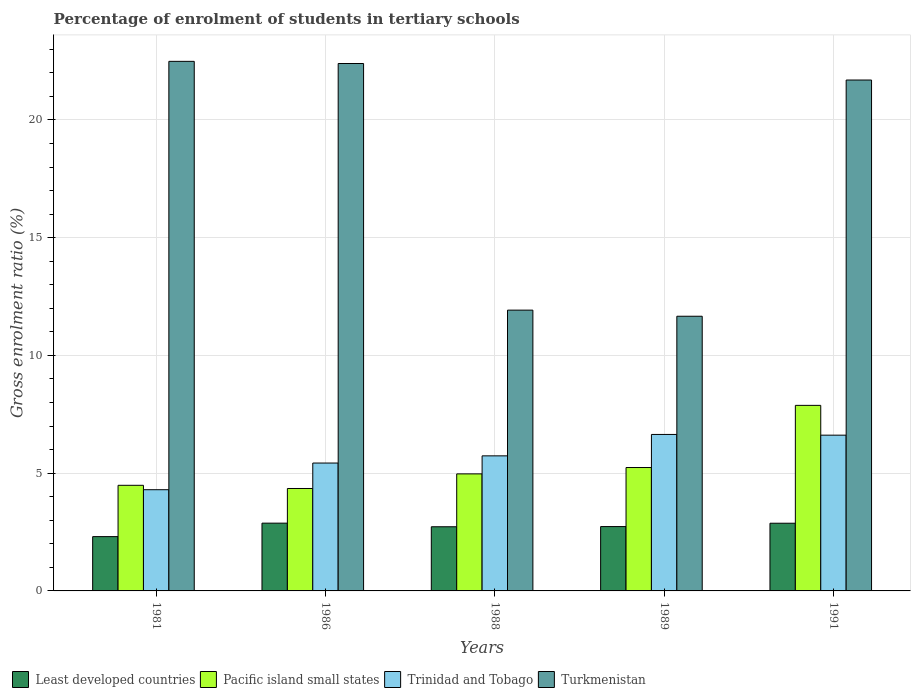How many bars are there on the 4th tick from the left?
Offer a very short reply. 4. What is the label of the 4th group of bars from the left?
Provide a succinct answer. 1989. In how many cases, is the number of bars for a given year not equal to the number of legend labels?
Your response must be concise. 0. What is the percentage of students enrolled in tertiary schools in Pacific island small states in 1986?
Give a very brief answer. 4.35. Across all years, what is the maximum percentage of students enrolled in tertiary schools in Least developed countries?
Offer a terse response. 2.88. Across all years, what is the minimum percentage of students enrolled in tertiary schools in Pacific island small states?
Your answer should be compact. 4.35. In which year was the percentage of students enrolled in tertiary schools in Turkmenistan maximum?
Your answer should be very brief. 1981. In which year was the percentage of students enrolled in tertiary schools in Turkmenistan minimum?
Your answer should be compact. 1989. What is the total percentage of students enrolled in tertiary schools in Trinidad and Tobago in the graph?
Keep it short and to the point. 28.73. What is the difference between the percentage of students enrolled in tertiary schools in Trinidad and Tobago in 1986 and that in 1988?
Provide a succinct answer. -0.31. What is the difference between the percentage of students enrolled in tertiary schools in Least developed countries in 1981 and the percentage of students enrolled in tertiary schools in Pacific island small states in 1989?
Make the answer very short. -2.93. What is the average percentage of students enrolled in tertiary schools in Pacific island small states per year?
Keep it short and to the point. 5.39. In the year 1981, what is the difference between the percentage of students enrolled in tertiary schools in Least developed countries and percentage of students enrolled in tertiary schools in Trinidad and Tobago?
Ensure brevity in your answer.  -1.99. In how many years, is the percentage of students enrolled in tertiary schools in Turkmenistan greater than 15 %?
Offer a terse response. 3. What is the ratio of the percentage of students enrolled in tertiary schools in Pacific island small states in 1988 to that in 1989?
Your answer should be compact. 0.95. What is the difference between the highest and the second highest percentage of students enrolled in tertiary schools in Least developed countries?
Your response must be concise. 0. What is the difference between the highest and the lowest percentage of students enrolled in tertiary schools in Least developed countries?
Your response must be concise. 0.57. In how many years, is the percentage of students enrolled in tertiary schools in Least developed countries greater than the average percentage of students enrolled in tertiary schools in Least developed countries taken over all years?
Your answer should be compact. 4. Is it the case that in every year, the sum of the percentage of students enrolled in tertiary schools in Trinidad and Tobago and percentage of students enrolled in tertiary schools in Turkmenistan is greater than the sum of percentage of students enrolled in tertiary schools in Least developed countries and percentage of students enrolled in tertiary schools in Pacific island small states?
Offer a terse response. Yes. What does the 3rd bar from the left in 1986 represents?
Offer a very short reply. Trinidad and Tobago. What does the 3rd bar from the right in 1988 represents?
Provide a short and direct response. Pacific island small states. How many bars are there?
Provide a succinct answer. 20. Are all the bars in the graph horizontal?
Keep it short and to the point. No. How many years are there in the graph?
Offer a very short reply. 5. What is the difference between two consecutive major ticks on the Y-axis?
Make the answer very short. 5. Does the graph contain any zero values?
Ensure brevity in your answer.  No. Does the graph contain grids?
Provide a short and direct response. Yes. How are the legend labels stacked?
Make the answer very short. Horizontal. What is the title of the graph?
Offer a terse response. Percentage of enrolment of students in tertiary schools. What is the label or title of the X-axis?
Your answer should be compact. Years. What is the Gross enrolment ratio (%) in Least developed countries in 1981?
Keep it short and to the point. 2.31. What is the Gross enrolment ratio (%) in Pacific island small states in 1981?
Your response must be concise. 4.49. What is the Gross enrolment ratio (%) in Trinidad and Tobago in 1981?
Ensure brevity in your answer.  4.3. What is the Gross enrolment ratio (%) in Turkmenistan in 1981?
Provide a short and direct response. 22.49. What is the Gross enrolment ratio (%) in Least developed countries in 1986?
Give a very brief answer. 2.88. What is the Gross enrolment ratio (%) in Pacific island small states in 1986?
Offer a very short reply. 4.35. What is the Gross enrolment ratio (%) of Trinidad and Tobago in 1986?
Your answer should be compact. 5.43. What is the Gross enrolment ratio (%) in Turkmenistan in 1986?
Keep it short and to the point. 22.4. What is the Gross enrolment ratio (%) in Least developed countries in 1988?
Your answer should be compact. 2.72. What is the Gross enrolment ratio (%) of Pacific island small states in 1988?
Your answer should be compact. 4.97. What is the Gross enrolment ratio (%) of Trinidad and Tobago in 1988?
Your answer should be compact. 5.74. What is the Gross enrolment ratio (%) of Turkmenistan in 1988?
Your answer should be compact. 11.92. What is the Gross enrolment ratio (%) of Least developed countries in 1989?
Make the answer very short. 2.73. What is the Gross enrolment ratio (%) of Pacific island small states in 1989?
Keep it short and to the point. 5.24. What is the Gross enrolment ratio (%) in Trinidad and Tobago in 1989?
Offer a terse response. 6.65. What is the Gross enrolment ratio (%) of Turkmenistan in 1989?
Your response must be concise. 11.66. What is the Gross enrolment ratio (%) of Least developed countries in 1991?
Make the answer very short. 2.87. What is the Gross enrolment ratio (%) of Pacific island small states in 1991?
Offer a terse response. 7.88. What is the Gross enrolment ratio (%) in Trinidad and Tobago in 1991?
Your answer should be compact. 6.61. What is the Gross enrolment ratio (%) in Turkmenistan in 1991?
Your answer should be very brief. 21.7. Across all years, what is the maximum Gross enrolment ratio (%) in Least developed countries?
Offer a very short reply. 2.88. Across all years, what is the maximum Gross enrolment ratio (%) of Pacific island small states?
Your answer should be compact. 7.88. Across all years, what is the maximum Gross enrolment ratio (%) of Trinidad and Tobago?
Your response must be concise. 6.65. Across all years, what is the maximum Gross enrolment ratio (%) of Turkmenistan?
Offer a terse response. 22.49. Across all years, what is the minimum Gross enrolment ratio (%) in Least developed countries?
Keep it short and to the point. 2.31. Across all years, what is the minimum Gross enrolment ratio (%) of Pacific island small states?
Make the answer very short. 4.35. Across all years, what is the minimum Gross enrolment ratio (%) of Trinidad and Tobago?
Your response must be concise. 4.3. Across all years, what is the minimum Gross enrolment ratio (%) of Turkmenistan?
Provide a succinct answer. 11.66. What is the total Gross enrolment ratio (%) of Least developed countries in the graph?
Your response must be concise. 13.52. What is the total Gross enrolment ratio (%) in Pacific island small states in the graph?
Provide a short and direct response. 26.93. What is the total Gross enrolment ratio (%) in Trinidad and Tobago in the graph?
Offer a terse response. 28.73. What is the total Gross enrolment ratio (%) of Turkmenistan in the graph?
Ensure brevity in your answer.  90.17. What is the difference between the Gross enrolment ratio (%) in Least developed countries in 1981 and that in 1986?
Your answer should be very brief. -0.57. What is the difference between the Gross enrolment ratio (%) in Pacific island small states in 1981 and that in 1986?
Offer a very short reply. 0.14. What is the difference between the Gross enrolment ratio (%) of Trinidad and Tobago in 1981 and that in 1986?
Make the answer very short. -1.13. What is the difference between the Gross enrolment ratio (%) of Turkmenistan in 1981 and that in 1986?
Offer a very short reply. 0.09. What is the difference between the Gross enrolment ratio (%) in Least developed countries in 1981 and that in 1988?
Offer a very short reply. -0.42. What is the difference between the Gross enrolment ratio (%) in Pacific island small states in 1981 and that in 1988?
Your response must be concise. -0.48. What is the difference between the Gross enrolment ratio (%) in Trinidad and Tobago in 1981 and that in 1988?
Offer a terse response. -1.44. What is the difference between the Gross enrolment ratio (%) in Turkmenistan in 1981 and that in 1988?
Ensure brevity in your answer.  10.57. What is the difference between the Gross enrolment ratio (%) in Least developed countries in 1981 and that in 1989?
Offer a terse response. -0.43. What is the difference between the Gross enrolment ratio (%) in Pacific island small states in 1981 and that in 1989?
Provide a succinct answer. -0.76. What is the difference between the Gross enrolment ratio (%) in Trinidad and Tobago in 1981 and that in 1989?
Provide a short and direct response. -2.35. What is the difference between the Gross enrolment ratio (%) of Turkmenistan in 1981 and that in 1989?
Keep it short and to the point. 10.82. What is the difference between the Gross enrolment ratio (%) in Least developed countries in 1981 and that in 1991?
Your answer should be compact. -0.57. What is the difference between the Gross enrolment ratio (%) in Pacific island small states in 1981 and that in 1991?
Offer a terse response. -3.39. What is the difference between the Gross enrolment ratio (%) in Trinidad and Tobago in 1981 and that in 1991?
Your response must be concise. -2.32. What is the difference between the Gross enrolment ratio (%) of Turkmenistan in 1981 and that in 1991?
Keep it short and to the point. 0.79. What is the difference between the Gross enrolment ratio (%) of Least developed countries in 1986 and that in 1988?
Your answer should be very brief. 0.15. What is the difference between the Gross enrolment ratio (%) of Pacific island small states in 1986 and that in 1988?
Provide a short and direct response. -0.62. What is the difference between the Gross enrolment ratio (%) in Trinidad and Tobago in 1986 and that in 1988?
Your answer should be compact. -0.31. What is the difference between the Gross enrolment ratio (%) in Turkmenistan in 1986 and that in 1988?
Give a very brief answer. 10.47. What is the difference between the Gross enrolment ratio (%) in Least developed countries in 1986 and that in 1989?
Offer a terse response. 0.15. What is the difference between the Gross enrolment ratio (%) of Pacific island small states in 1986 and that in 1989?
Keep it short and to the point. -0.89. What is the difference between the Gross enrolment ratio (%) in Trinidad and Tobago in 1986 and that in 1989?
Provide a short and direct response. -1.21. What is the difference between the Gross enrolment ratio (%) of Turkmenistan in 1986 and that in 1989?
Your response must be concise. 10.73. What is the difference between the Gross enrolment ratio (%) in Least developed countries in 1986 and that in 1991?
Provide a succinct answer. 0. What is the difference between the Gross enrolment ratio (%) of Pacific island small states in 1986 and that in 1991?
Offer a very short reply. -3.53. What is the difference between the Gross enrolment ratio (%) in Trinidad and Tobago in 1986 and that in 1991?
Provide a short and direct response. -1.18. What is the difference between the Gross enrolment ratio (%) of Turkmenistan in 1986 and that in 1991?
Your answer should be compact. 0.7. What is the difference between the Gross enrolment ratio (%) of Least developed countries in 1988 and that in 1989?
Offer a terse response. -0.01. What is the difference between the Gross enrolment ratio (%) of Pacific island small states in 1988 and that in 1989?
Offer a terse response. -0.27. What is the difference between the Gross enrolment ratio (%) of Trinidad and Tobago in 1988 and that in 1989?
Your response must be concise. -0.91. What is the difference between the Gross enrolment ratio (%) of Turkmenistan in 1988 and that in 1989?
Make the answer very short. 0.26. What is the difference between the Gross enrolment ratio (%) in Least developed countries in 1988 and that in 1991?
Offer a terse response. -0.15. What is the difference between the Gross enrolment ratio (%) in Pacific island small states in 1988 and that in 1991?
Provide a succinct answer. -2.91. What is the difference between the Gross enrolment ratio (%) in Trinidad and Tobago in 1988 and that in 1991?
Give a very brief answer. -0.88. What is the difference between the Gross enrolment ratio (%) of Turkmenistan in 1988 and that in 1991?
Make the answer very short. -9.77. What is the difference between the Gross enrolment ratio (%) in Least developed countries in 1989 and that in 1991?
Keep it short and to the point. -0.14. What is the difference between the Gross enrolment ratio (%) of Pacific island small states in 1989 and that in 1991?
Give a very brief answer. -2.64. What is the difference between the Gross enrolment ratio (%) of Trinidad and Tobago in 1989 and that in 1991?
Your answer should be very brief. 0.03. What is the difference between the Gross enrolment ratio (%) of Turkmenistan in 1989 and that in 1991?
Your response must be concise. -10.03. What is the difference between the Gross enrolment ratio (%) in Least developed countries in 1981 and the Gross enrolment ratio (%) in Pacific island small states in 1986?
Keep it short and to the point. -2.04. What is the difference between the Gross enrolment ratio (%) of Least developed countries in 1981 and the Gross enrolment ratio (%) of Trinidad and Tobago in 1986?
Your response must be concise. -3.12. What is the difference between the Gross enrolment ratio (%) of Least developed countries in 1981 and the Gross enrolment ratio (%) of Turkmenistan in 1986?
Your response must be concise. -20.09. What is the difference between the Gross enrolment ratio (%) of Pacific island small states in 1981 and the Gross enrolment ratio (%) of Trinidad and Tobago in 1986?
Offer a terse response. -0.95. What is the difference between the Gross enrolment ratio (%) in Pacific island small states in 1981 and the Gross enrolment ratio (%) in Turkmenistan in 1986?
Ensure brevity in your answer.  -17.91. What is the difference between the Gross enrolment ratio (%) in Trinidad and Tobago in 1981 and the Gross enrolment ratio (%) in Turkmenistan in 1986?
Give a very brief answer. -18.1. What is the difference between the Gross enrolment ratio (%) of Least developed countries in 1981 and the Gross enrolment ratio (%) of Pacific island small states in 1988?
Offer a terse response. -2.66. What is the difference between the Gross enrolment ratio (%) of Least developed countries in 1981 and the Gross enrolment ratio (%) of Trinidad and Tobago in 1988?
Your answer should be very brief. -3.43. What is the difference between the Gross enrolment ratio (%) of Least developed countries in 1981 and the Gross enrolment ratio (%) of Turkmenistan in 1988?
Make the answer very short. -9.62. What is the difference between the Gross enrolment ratio (%) in Pacific island small states in 1981 and the Gross enrolment ratio (%) in Trinidad and Tobago in 1988?
Your answer should be very brief. -1.25. What is the difference between the Gross enrolment ratio (%) in Pacific island small states in 1981 and the Gross enrolment ratio (%) in Turkmenistan in 1988?
Keep it short and to the point. -7.44. What is the difference between the Gross enrolment ratio (%) in Trinidad and Tobago in 1981 and the Gross enrolment ratio (%) in Turkmenistan in 1988?
Give a very brief answer. -7.63. What is the difference between the Gross enrolment ratio (%) of Least developed countries in 1981 and the Gross enrolment ratio (%) of Pacific island small states in 1989?
Ensure brevity in your answer.  -2.93. What is the difference between the Gross enrolment ratio (%) in Least developed countries in 1981 and the Gross enrolment ratio (%) in Trinidad and Tobago in 1989?
Your response must be concise. -4.34. What is the difference between the Gross enrolment ratio (%) of Least developed countries in 1981 and the Gross enrolment ratio (%) of Turkmenistan in 1989?
Your response must be concise. -9.36. What is the difference between the Gross enrolment ratio (%) of Pacific island small states in 1981 and the Gross enrolment ratio (%) of Trinidad and Tobago in 1989?
Your answer should be very brief. -2.16. What is the difference between the Gross enrolment ratio (%) in Pacific island small states in 1981 and the Gross enrolment ratio (%) in Turkmenistan in 1989?
Give a very brief answer. -7.18. What is the difference between the Gross enrolment ratio (%) of Trinidad and Tobago in 1981 and the Gross enrolment ratio (%) of Turkmenistan in 1989?
Ensure brevity in your answer.  -7.37. What is the difference between the Gross enrolment ratio (%) of Least developed countries in 1981 and the Gross enrolment ratio (%) of Pacific island small states in 1991?
Your response must be concise. -5.57. What is the difference between the Gross enrolment ratio (%) in Least developed countries in 1981 and the Gross enrolment ratio (%) in Trinidad and Tobago in 1991?
Offer a very short reply. -4.31. What is the difference between the Gross enrolment ratio (%) in Least developed countries in 1981 and the Gross enrolment ratio (%) in Turkmenistan in 1991?
Give a very brief answer. -19.39. What is the difference between the Gross enrolment ratio (%) in Pacific island small states in 1981 and the Gross enrolment ratio (%) in Trinidad and Tobago in 1991?
Your answer should be compact. -2.13. What is the difference between the Gross enrolment ratio (%) of Pacific island small states in 1981 and the Gross enrolment ratio (%) of Turkmenistan in 1991?
Provide a short and direct response. -17.21. What is the difference between the Gross enrolment ratio (%) of Trinidad and Tobago in 1981 and the Gross enrolment ratio (%) of Turkmenistan in 1991?
Give a very brief answer. -17.4. What is the difference between the Gross enrolment ratio (%) of Least developed countries in 1986 and the Gross enrolment ratio (%) of Pacific island small states in 1988?
Your response must be concise. -2.09. What is the difference between the Gross enrolment ratio (%) in Least developed countries in 1986 and the Gross enrolment ratio (%) in Trinidad and Tobago in 1988?
Your answer should be very brief. -2.86. What is the difference between the Gross enrolment ratio (%) in Least developed countries in 1986 and the Gross enrolment ratio (%) in Turkmenistan in 1988?
Offer a very short reply. -9.05. What is the difference between the Gross enrolment ratio (%) in Pacific island small states in 1986 and the Gross enrolment ratio (%) in Trinidad and Tobago in 1988?
Give a very brief answer. -1.39. What is the difference between the Gross enrolment ratio (%) in Pacific island small states in 1986 and the Gross enrolment ratio (%) in Turkmenistan in 1988?
Give a very brief answer. -7.57. What is the difference between the Gross enrolment ratio (%) in Trinidad and Tobago in 1986 and the Gross enrolment ratio (%) in Turkmenistan in 1988?
Your answer should be compact. -6.49. What is the difference between the Gross enrolment ratio (%) of Least developed countries in 1986 and the Gross enrolment ratio (%) of Pacific island small states in 1989?
Your response must be concise. -2.36. What is the difference between the Gross enrolment ratio (%) of Least developed countries in 1986 and the Gross enrolment ratio (%) of Trinidad and Tobago in 1989?
Give a very brief answer. -3.77. What is the difference between the Gross enrolment ratio (%) of Least developed countries in 1986 and the Gross enrolment ratio (%) of Turkmenistan in 1989?
Provide a succinct answer. -8.79. What is the difference between the Gross enrolment ratio (%) of Pacific island small states in 1986 and the Gross enrolment ratio (%) of Trinidad and Tobago in 1989?
Provide a short and direct response. -2.3. What is the difference between the Gross enrolment ratio (%) of Pacific island small states in 1986 and the Gross enrolment ratio (%) of Turkmenistan in 1989?
Offer a very short reply. -7.32. What is the difference between the Gross enrolment ratio (%) of Trinidad and Tobago in 1986 and the Gross enrolment ratio (%) of Turkmenistan in 1989?
Your response must be concise. -6.23. What is the difference between the Gross enrolment ratio (%) of Least developed countries in 1986 and the Gross enrolment ratio (%) of Pacific island small states in 1991?
Make the answer very short. -5. What is the difference between the Gross enrolment ratio (%) of Least developed countries in 1986 and the Gross enrolment ratio (%) of Trinidad and Tobago in 1991?
Your answer should be very brief. -3.74. What is the difference between the Gross enrolment ratio (%) in Least developed countries in 1986 and the Gross enrolment ratio (%) in Turkmenistan in 1991?
Offer a terse response. -18.82. What is the difference between the Gross enrolment ratio (%) in Pacific island small states in 1986 and the Gross enrolment ratio (%) in Trinidad and Tobago in 1991?
Give a very brief answer. -2.27. What is the difference between the Gross enrolment ratio (%) in Pacific island small states in 1986 and the Gross enrolment ratio (%) in Turkmenistan in 1991?
Your answer should be very brief. -17.35. What is the difference between the Gross enrolment ratio (%) in Trinidad and Tobago in 1986 and the Gross enrolment ratio (%) in Turkmenistan in 1991?
Your answer should be compact. -16.27. What is the difference between the Gross enrolment ratio (%) of Least developed countries in 1988 and the Gross enrolment ratio (%) of Pacific island small states in 1989?
Your answer should be very brief. -2.52. What is the difference between the Gross enrolment ratio (%) in Least developed countries in 1988 and the Gross enrolment ratio (%) in Trinidad and Tobago in 1989?
Provide a succinct answer. -3.92. What is the difference between the Gross enrolment ratio (%) in Least developed countries in 1988 and the Gross enrolment ratio (%) in Turkmenistan in 1989?
Offer a very short reply. -8.94. What is the difference between the Gross enrolment ratio (%) of Pacific island small states in 1988 and the Gross enrolment ratio (%) of Trinidad and Tobago in 1989?
Provide a short and direct response. -1.68. What is the difference between the Gross enrolment ratio (%) of Pacific island small states in 1988 and the Gross enrolment ratio (%) of Turkmenistan in 1989?
Ensure brevity in your answer.  -6.69. What is the difference between the Gross enrolment ratio (%) of Trinidad and Tobago in 1988 and the Gross enrolment ratio (%) of Turkmenistan in 1989?
Your answer should be compact. -5.93. What is the difference between the Gross enrolment ratio (%) of Least developed countries in 1988 and the Gross enrolment ratio (%) of Pacific island small states in 1991?
Your answer should be very brief. -5.16. What is the difference between the Gross enrolment ratio (%) of Least developed countries in 1988 and the Gross enrolment ratio (%) of Trinidad and Tobago in 1991?
Your answer should be very brief. -3.89. What is the difference between the Gross enrolment ratio (%) in Least developed countries in 1988 and the Gross enrolment ratio (%) in Turkmenistan in 1991?
Your answer should be very brief. -18.97. What is the difference between the Gross enrolment ratio (%) of Pacific island small states in 1988 and the Gross enrolment ratio (%) of Trinidad and Tobago in 1991?
Your response must be concise. -1.64. What is the difference between the Gross enrolment ratio (%) in Pacific island small states in 1988 and the Gross enrolment ratio (%) in Turkmenistan in 1991?
Provide a succinct answer. -16.73. What is the difference between the Gross enrolment ratio (%) in Trinidad and Tobago in 1988 and the Gross enrolment ratio (%) in Turkmenistan in 1991?
Offer a terse response. -15.96. What is the difference between the Gross enrolment ratio (%) in Least developed countries in 1989 and the Gross enrolment ratio (%) in Pacific island small states in 1991?
Provide a short and direct response. -5.15. What is the difference between the Gross enrolment ratio (%) in Least developed countries in 1989 and the Gross enrolment ratio (%) in Trinidad and Tobago in 1991?
Offer a terse response. -3.88. What is the difference between the Gross enrolment ratio (%) of Least developed countries in 1989 and the Gross enrolment ratio (%) of Turkmenistan in 1991?
Offer a very short reply. -18.96. What is the difference between the Gross enrolment ratio (%) in Pacific island small states in 1989 and the Gross enrolment ratio (%) in Trinidad and Tobago in 1991?
Your response must be concise. -1.37. What is the difference between the Gross enrolment ratio (%) in Pacific island small states in 1989 and the Gross enrolment ratio (%) in Turkmenistan in 1991?
Your response must be concise. -16.46. What is the difference between the Gross enrolment ratio (%) in Trinidad and Tobago in 1989 and the Gross enrolment ratio (%) in Turkmenistan in 1991?
Keep it short and to the point. -15.05. What is the average Gross enrolment ratio (%) in Least developed countries per year?
Your answer should be very brief. 2.7. What is the average Gross enrolment ratio (%) of Pacific island small states per year?
Provide a short and direct response. 5.39. What is the average Gross enrolment ratio (%) of Trinidad and Tobago per year?
Offer a terse response. 5.75. What is the average Gross enrolment ratio (%) in Turkmenistan per year?
Provide a short and direct response. 18.03. In the year 1981, what is the difference between the Gross enrolment ratio (%) of Least developed countries and Gross enrolment ratio (%) of Pacific island small states?
Offer a very short reply. -2.18. In the year 1981, what is the difference between the Gross enrolment ratio (%) of Least developed countries and Gross enrolment ratio (%) of Trinidad and Tobago?
Your answer should be very brief. -1.99. In the year 1981, what is the difference between the Gross enrolment ratio (%) in Least developed countries and Gross enrolment ratio (%) in Turkmenistan?
Make the answer very short. -20.18. In the year 1981, what is the difference between the Gross enrolment ratio (%) in Pacific island small states and Gross enrolment ratio (%) in Trinidad and Tobago?
Make the answer very short. 0.19. In the year 1981, what is the difference between the Gross enrolment ratio (%) of Pacific island small states and Gross enrolment ratio (%) of Turkmenistan?
Provide a succinct answer. -18. In the year 1981, what is the difference between the Gross enrolment ratio (%) of Trinidad and Tobago and Gross enrolment ratio (%) of Turkmenistan?
Your answer should be compact. -18.19. In the year 1986, what is the difference between the Gross enrolment ratio (%) of Least developed countries and Gross enrolment ratio (%) of Pacific island small states?
Offer a terse response. -1.47. In the year 1986, what is the difference between the Gross enrolment ratio (%) of Least developed countries and Gross enrolment ratio (%) of Trinidad and Tobago?
Your response must be concise. -2.55. In the year 1986, what is the difference between the Gross enrolment ratio (%) of Least developed countries and Gross enrolment ratio (%) of Turkmenistan?
Offer a terse response. -19.52. In the year 1986, what is the difference between the Gross enrolment ratio (%) of Pacific island small states and Gross enrolment ratio (%) of Trinidad and Tobago?
Provide a succinct answer. -1.08. In the year 1986, what is the difference between the Gross enrolment ratio (%) of Pacific island small states and Gross enrolment ratio (%) of Turkmenistan?
Provide a short and direct response. -18.05. In the year 1986, what is the difference between the Gross enrolment ratio (%) in Trinidad and Tobago and Gross enrolment ratio (%) in Turkmenistan?
Your answer should be very brief. -16.97. In the year 1988, what is the difference between the Gross enrolment ratio (%) in Least developed countries and Gross enrolment ratio (%) in Pacific island small states?
Keep it short and to the point. -2.25. In the year 1988, what is the difference between the Gross enrolment ratio (%) of Least developed countries and Gross enrolment ratio (%) of Trinidad and Tobago?
Your response must be concise. -3.01. In the year 1988, what is the difference between the Gross enrolment ratio (%) of Least developed countries and Gross enrolment ratio (%) of Turkmenistan?
Give a very brief answer. -9.2. In the year 1988, what is the difference between the Gross enrolment ratio (%) in Pacific island small states and Gross enrolment ratio (%) in Trinidad and Tobago?
Offer a very short reply. -0.77. In the year 1988, what is the difference between the Gross enrolment ratio (%) of Pacific island small states and Gross enrolment ratio (%) of Turkmenistan?
Your answer should be very brief. -6.95. In the year 1988, what is the difference between the Gross enrolment ratio (%) in Trinidad and Tobago and Gross enrolment ratio (%) in Turkmenistan?
Provide a short and direct response. -6.19. In the year 1989, what is the difference between the Gross enrolment ratio (%) in Least developed countries and Gross enrolment ratio (%) in Pacific island small states?
Ensure brevity in your answer.  -2.51. In the year 1989, what is the difference between the Gross enrolment ratio (%) of Least developed countries and Gross enrolment ratio (%) of Trinidad and Tobago?
Give a very brief answer. -3.91. In the year 1989, what is the difference between the Gross enrolment ratio (%) in Least developed countries and Gross enrolment ratio (%) in Turkmenistan?
Provide a succinct answer. -8.93. In the year 1989, what is the difference between the Gross enrolment ratio (%) in Pacific island small states and Gross enrolment ratio (%) in Trinidad and Tobago?
Keep it short and to the point. -1.4. In the year 1989, what is the difference between the Gross enrolment ratio (%) of Pacific island small states and Gross enrolment ratio (%) of Turkmenistan?
Your answer should be very brief. -6.42. In the year 1989, what is the difference between the Gross enrolment ratio (%) of Trinidad and Tobago and Gross enrolment ratio (%) of Turkmenistan?
Provide a succinct answer. -5.02. In the year 1991, what is the difference between the Gross enrolment ratio (%) in Least developed countries and Gross enrolment ratio (%) in Pacific island small states?
Your response must be concise. -5.01. In the year 1991, what is the difference between the Gross enrolment ratio (%) in Least developed countries and Gross enrolment ratio (%) in Trinidad and Tobago?
Provide a succinct answer. -3.74. In the year 1991, what is the difference between the Gross enrolment ratio (%) of Least developed countries and Gross enrolment ratio (%) of Turkmenistan?
Offer a very short reply. -18.82. In the year 1991, what is the difference between the Gross enrolment ratio (%) of Pacific island small states and Gross enrolment ratio (%) of Trinidad and Tobago?
Offer a terse response. 1.27. In the year 1991, what is the difference between the Gross enrolment ratio (%) in Pacific island small states and Gross enrolment ratio (%) in Turkmenistan?
Offer a terse response. -13.82. In the year 1991, what is the difference between the Gross enrolment ratio (%) in Trinidad and Tobago and Gross enrolment ratio (%) in Turkmenistan?
Offer a very short reply. -15.08. What is the ratio of the Gross enrolment ratio (%) in Least developed countries in 1981 to that in 1986?
Offer a terse response. 0.8. What is the ratio of the Gross enrolment ratio (%) in Pacific island small states in 1981 to that in 1986?
Your response must be concise. 1.03. What is the ratio of the Gross enrolment ratio (%) in Trinidad and Tobago in 1981 to that in 1986?
Your response must be concise. 0.79. What is the ratio of the Gross enrolment ratio (%) in Least developed countries in 1981 to that in 1988?
Provide a succinct answer. 0.85. What is the ratio of the Gross enrolment ratio (%) in Pacific island small states in 1981 to that in 1988?
Provide a short and direct response. 0.9. What is the ratio of the Gross enrolment ratio (%) in Trinidad and Tobago in 1981 to that in 1988?
Ensure brevity in your answer.  0.75. What is the ratio of the Gross enrolment ratio (%) of Turkmenistan in 1981 to that in 1988?
Give a very brief answer. 1.89. What is the ratio of the Gross enrolment ratio (%) in Least developed countries in 1981 to that in 1989?
Your answer should be very brief. 0.84. What is the ratio of the Gross enrolment ratio (%) in Pacific island small states in 1981 to that in 1989?
Make the answer very short. 0.86. What is the ratio of the Gross enrolment ratio (%) in Trinidad and Tobago in 1981 to that in 1989?
Your answer should be very brief. 0.65. What is the ratio of the Gross enrolment ratio (%) of Turkmenistan in 1981 to that in 1989?
Provide a short and direct response. 1.93. What is the ratio of the Gross enrolment ratio (%) in Least developed countries in 1981 to that in 1991?
Give a very brief answer. 0.8. What is the ratio of the Gross enrolment ratio (%) in Pacific island small states in 1981 to that in 1991?
Provide a succinct answer. 0.57. What is the ratio of the Gross enrolment ratio (%) in Trinidad and Tobago in 1981 to that in 1991?
Offer a very short reply. 0.65. What is the ratio of the Gross enrolment ratio (%) in Turkmenistan in 1981 to that in 1991?
Keep it short and to the point. 1.04. What is the ratio of the Gross enrolment ratio (%) of Least developed countries in 1986 to that in 1988?
Provide a short and direct response. 1.06. What is the ratio of the Gross enrolment ratio (%) in Pacific island small states in 1986 to that in 1988?
Ensure brevity in your answer.  0.88. What is the ratio of the Gross enrolment ratio (%) in Trinidad and Tobago in 1986 to that in 1988?
Offer a very short reply. 0.95. What is the ratio of the Gross enrolment ratio (%) of Turkmenistan in 1986 to that in 1988?
Keep it short and to the point. 1.88. What is the ratio of the Gross enrolment ratio (%) of Least developed countries in 1986 to that in 1989?
Your answer should be very brief. 1.05. What is the ratio of the Gross enrolment ratio (%) in Pacific island small states in 1986 to that in 1989?
Give a very brief answer. 0.83. What is the ratio of the Gross enrolment ratio (%) of Trinidad and Tobago in 1986 to that in 1989?
Offer a very short reply. 0.82. What is the ratio of the Gross enrolment ratio (%) of Turkmenistan in 1986 to that in 1989?
Offer a very short reply. 1.92. What is the ratio of the Gross enrolment ratio (%) in Pacific island small states in 1986 to that in 1991?
Your answer should be very brief. 0.55. What is the ratio of the Gross enrolment ratio (%) in Trinidad and Tobago in 1986 to that in 1991?
Ensure brevity in your answer.  0.82. What is the ratio of the Gross enrolment ratio (%) of Turkmenistan in 1986 to that in 1991?
Provide a short and direct response. 1.03. What is the ratio of the Gross enrolment ratio (%) in Least developed countries in 1988 to that in 1989?
Make the answer very short. 1. What is the ratio of the Gross enrolment ratio (%) in Pacific island small states in 1988 to that in 1989?
Give a very brief answer. 0.95. What is the ratio of the Gross enrolment ratio (%) of Trinidad and Tobago in 1988 to that in 1989?
Make the answer very short. 0.86. What is the ratio of the Gross enrolment ratio (%) in Turkmenistan in 1988 to that in 1989?
Provide a succinct answer. 1.02. What is the ratio of the Gross enrolment ratio (%) of Least developed countries in 1988 to that in 1991?
Ensure brevity in your answer.  0.95. What is the ratio of the Gross enrolment ratio (%) of Pacific island small states in 1988 to that in 1991?
Keep it short and to the point. 0.63. What is the ratio of the Gross enrolment ratio (%) of Trinidad and Tobago in 1988 to that in 1991?
Give a very brief answer. 0.87. What is the ratio of the Gross enrolment ratio (%) in Turkmenistan in 1988 to that in 1991?
Your answer should be compact. 0.55. What is the ratio of the Gross enrolment ratio (%) of Least developed countries in 1989 to that in 1991?
Your answer should be compact. 0.95. What is the ratio of the Gross enrolment ratio (%) in Pacific island small states in 1989 to that in 1991?
Make the answer very short. 0.67. What is the ratio of the Gross enrolment ratio (%) of Trinidad and Tobago in 1989 to that in 1991?
Provide a short and direct response. 1. What is the ratio of the Gross enrolment ratio (%) in Turkmenistan in 1989 to that in 1991?
Your answer should be very brief. 0.54. What is the difference between the highest and the second highest Gross enrolment ratio (%) in Least developed countries?
Your answer should be compact. 0. What is the difference between the highest and the second highest Gross enrolment ratio (%) in Pacific island small states?
Keep it short and to the point. 2.64. What is the difference between the highest and the second highest Gross enrolment ratio (%) in Trinidad and Tobago?
Your response must be concise. 0.03. What is the difference between the highest and the second highest Gross enrolment ratio (%) of Turkmenistan?
Provide a succinct answer. 0.09. What is the difference between the highest and the lowest Gross enrolment ratio (%) of Least developed countries?
Offer a terse response. 0.57. What is the difference between the highest and the lowest Gross enrolment ratio (%) in Pacific island small states?
Your answer should be very brief. 3.53. What is the difference between the highest and the lowest Gross enrolment ratio (%) of Trinidad and Tobago?
Your answer should be compact. 2.35. What is the difference between the highest and the lowest Gross enrolment ratio (%) of Turkmenistan?
Offer a terse response. 10.82. 